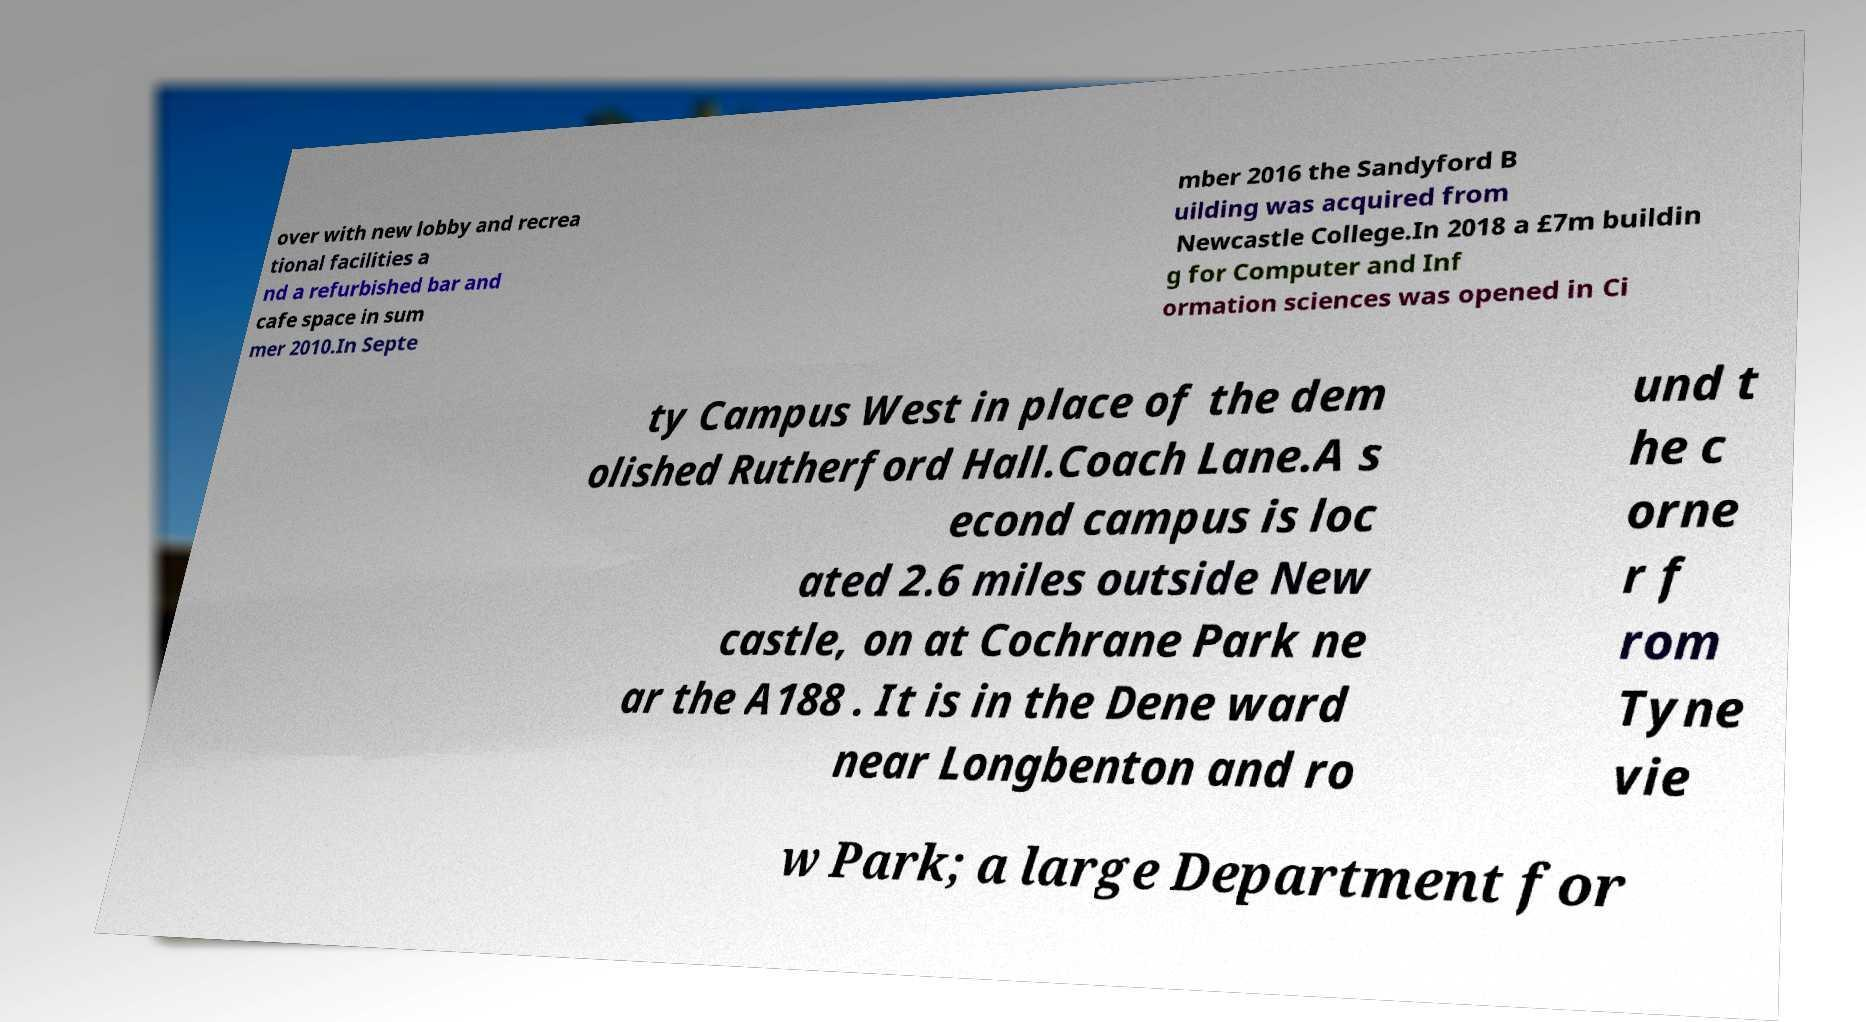I need the written content from this picture converted into text. Can you do that? over with new lobby and recrea tional facilities a nd a refurbished bar and cafe space in sum mer 2010.In Septe mber 2016 the Sandyford B uilding was acquired from Newcastle College.In 2018 a £7m buildin g for Computer and Inf ormation sciences was opened in Ci ty Campus West in place of the dem olished Rutherford Hall.Coach Lane.A s econd campus is loc ated 2.6 miles outside New castle, on at Cochrane Park ne ar the A188 . It is in the Dene ward near Longbenton and ro und t he c orne r f rom Tyne vie w Park; a large Department for 